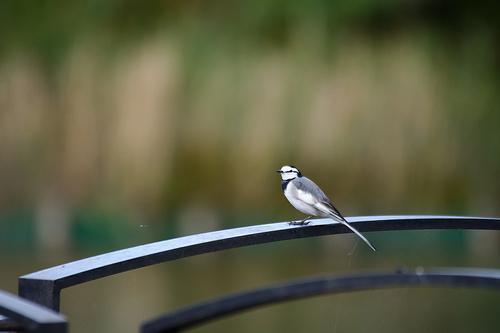How many birds are in this photo?
Give a very brief answer. 1. 